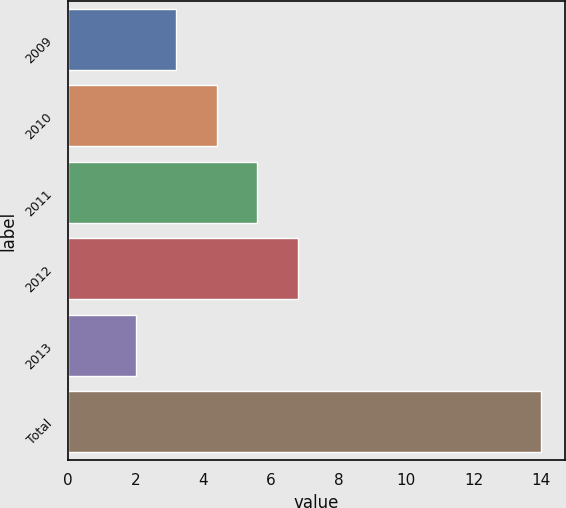<chart> <loc_0><loc_0><loc_500><loc_500><bar_chart><fcel>2009<fcel>2010<fcel>2011<fcel>2012<fcel>2013<fcel>Total<nl><fcel>3.2<fcel>4.4<fcel>5.6<fcel>6.8<fcel>2<fcel>14<nl></chart> 